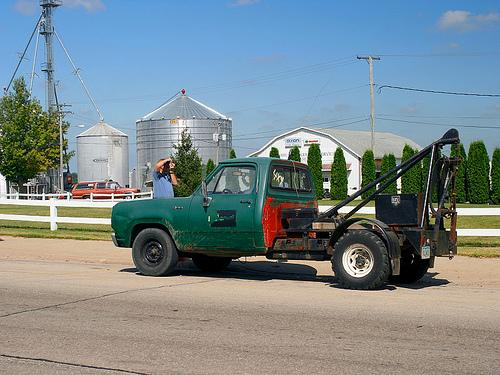What color was this truck originally? red 